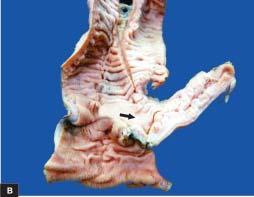what contains necrotic debris?
Answer the question using a single word or phrase. Lumen 